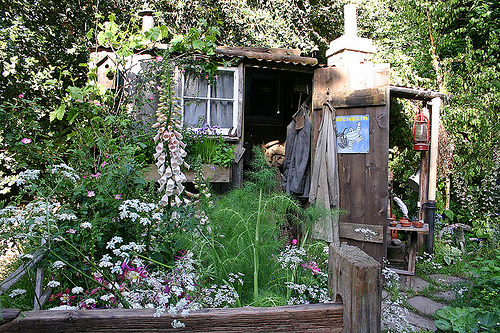<image>
Is the window behind the flowers? Yes. From this viewpoint, the window is positioned behind the flowers, with the flowers partially or fully occluding the window. 